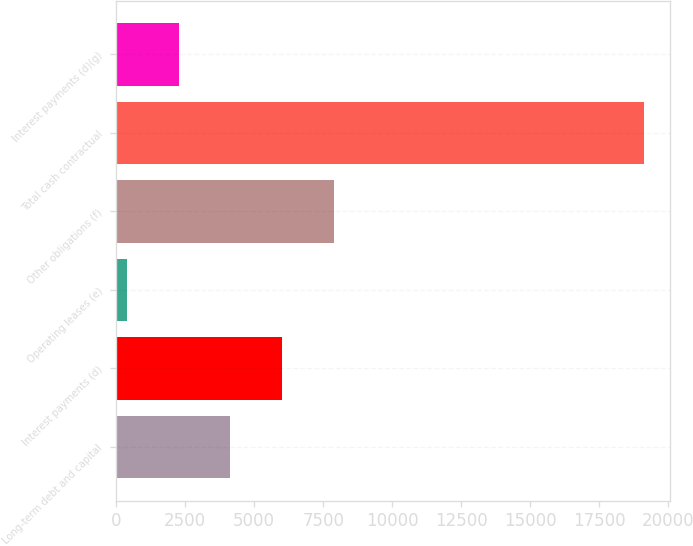Convert chart to OTSL. <chart><loc_0><loc_0><loc_500><loc_500><bar_chart><fcel>Long-term debt and capital<fcel>Interest payments (d)<fcel>Operating leases (e)<fcel>Other obligations (f)<fcel>Total cash contractual<fcel>Interest payments (d)(g)<nl><fcel>4138.8<fcel>6012.2<fcel>392<fcel>7885.6<fcel>19126<fcel>2265.4<nl></chart> 